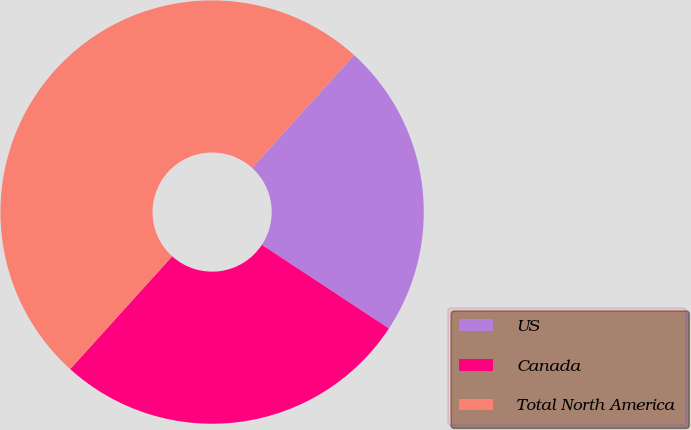<chart> <loc_0><loc_0><loc_500><loc_500><pie_chart><fcel>US<fcel>Canada<fcel>Total North America<nl><fcel>22.57%<fcel>27.43%<fcel>50.0%<nl></chart> 